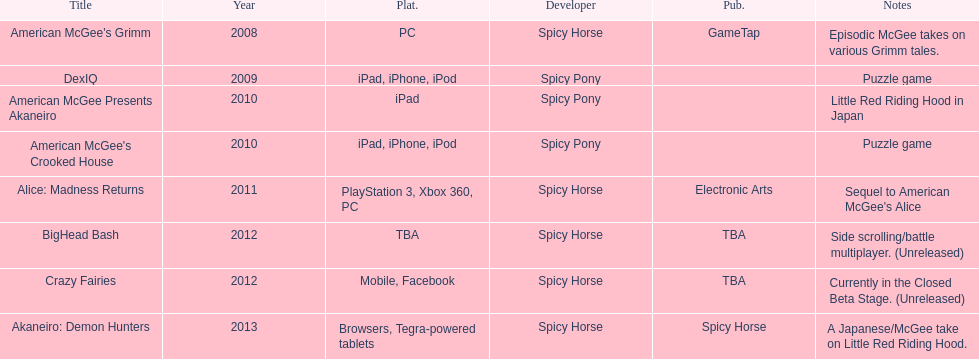How many platforms did american mcgee's grimm run on? 1. Write the full table. {'header': ['Title', 'Year', 'Plat.', 'Developer', 'Pub.', 'Notes'], 'rows': [["American McGee's Grimm", '2008', 'PC', 'Spicy Horse', 'GameTap', 'Episodic McGee takes on various Grimm tales.'], ['DexIQ', '2009', 'iPad, iPhone, iPod', 'Spicy Pony', '', 'Puzzle game'], ['American McGee Presents Akaneiro', '2010', 'iPad', 'Spicy Pony', '', 'Little Red Riding Hood in Japan'], ["American McGee's Crooked House", '2010', 'iPad, iPhone, iPod', 'Spicy Pony', '', 'Puzzle game'], ['Alice: Madness Returns', '2011', 'PlayStation 3, Xbox 360, PC', 'Spicy Horse', 'Electronic Arts', "Sequel to American McGee's Alice"], ['BigHead Bash', '2012', 'TBA', 'Spicy Horse', 'TBA', 'Side scrolling/battle multiplayer. (Unreleased)'], ['Crazy Fairies', '2012', 'Mobile, Facebook', 'Spicy Horse', 'TBA', 'Currently in the Closed Beta Stage. (Unreleased)'], ['Akaneiro: Demon Hunters', '2013', 'Browsers, Tegra-powered tablets', 'Spicy Horse', 'Spicy Horse', 'A Japanese/McGee take on Little Red Riding Hood.']]} 